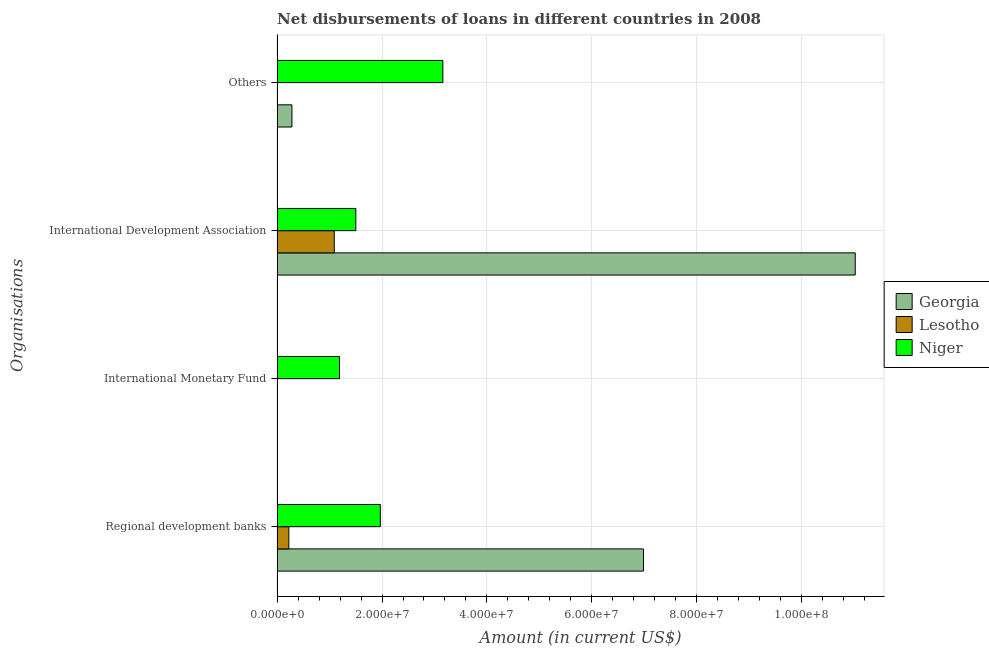How many different coloured bars are there?
Offer a terse response. 3. Are the number of bars per tick equal to the number of legend labels?
Your answer should be very brief. No. How many bars are there on the 1st tick from the bottom?
Make the answer very short. 3. What is the label of the 3rd group of bars from the top?
Provide a succinct answer. International Monetary Fund. What is the amount of loan disimbursed by international monetary fund in Niger?
Your answer should be very brief. 1.19e+07. Across all countries, what is the maximum amount of loan disimbursed by international monetary fund?
Offer a very short reply. 1.19e+07. In which country was the amount of loan disimbursed by international monetary fund maximum?
Offer a terse response. Niger. What is the total amount of loan disimbursed by other organisations in the graph?
Your response must be concise. 3.44e+07. What is the difference between the amount of loan disimbursed by international development association in Niger and that in Lesotho?
Make the answer very short. 4.11e+06. What is the difference between the amount of loan disimbursed by other organisations in Lesotho and the amount of loan disimbursed by international development association in Georgia?
Offer a very short reply. -1.10e+08. What is the average amount of loan disimbursed by international development association per country?
Ensure brevity in your answer.  4.54e+07. What is the difference between the amount of loan disimbursed by other organisations and amount of loan disimbursed by international development association in Niger?
Your answer should be compact. 1.66e+07. In how many countries, is the amount of loan disimbursed by international development association greater than 40000000 US$?
Provide a succinct answer. 1. What is the ratio of the amount of loan disimbursed by regional development banks in Niger to that in Georgia?
Your response must be concise. 0.28. Is the difference between the amount of loan disimbursed by regional development banks in Georgia and Niger greater than the difference between the amount of loan disimbursed by other organisations in Georgia and Niger?
Keep it short and to the point. Yes. What is the difference between the highest and the second highest amount of loan disimbursed by international development association?
Keep it short and to the point. 9.52e+07. What is the difference between the highest and the lowest amount of loan disimbursed by other organisations?
Offer a very short reply. 3.16e+07. Are all the bars in the graph horizontal?
Provide a succinct answer. Yes. Are the values on the major ticks of X-axis written in scientific E-notation?
Offer a very short reply. Yes. Does the graph contain any zero values?
Make the answer very short. Yes. Does the graph contain grids?
Offer a very short reply. Yes. Where does the legend appear in the graph?
Keep it short and to the point. Center right. How are the legend labels stacked?
Give a very brief answer. Vertical. What is the title of the graph?
Give a very brief answer. Net disbursements of loans in different countries in 2008. Does "High income: nonOECD" appear as one of the legend labels in the graph?
Ensure brevity in your answer.  No. What is the label or title of the X-axis?
Offer a terse response. Amount (in current US$). What is the label or title of the Y-axis?
Provide a short and direct response. Organisations. What is the Amount (in current US$) in Georgia in Regional development banks?
Your answer should be very brief. 6.99e+07. What is the Amount (in current US$) of Lesotho in Regional development banks?
Make the answer very short. 2.23e+06. What is the Amount (in current US$) of Niger in Regional development banks?
Make the answer very short. 1.97e+07. What is the Amount (in current US$) of Lesotho in International Monetary Fund?
Give a very brief answer. 0. What is the Amount (in current US$) in Niger in International Monetary Fund?
Keep it short and to the point. 1.19e+07. What is the Amount (in current US$) in Georgia in International Development Association?
Offer a terse response. 1.10e+08. What is the Amount (in current US$) in Lesotho in International Development Association?
Your answer should be compact. 1.09e+07. What is the Amount (in current US$) in Niger in International Development Association?
Your answer should be compact. 1.50e+07. What is the Amount (in current US$) in Georgia in Others?
Offer a very short reply. 2.82e+06. What is the Amount (in current US$) of Lesotho in Others?
Make the answer very short. 0. What is the Amount (in current US$) in Niger in Others?
Your answer should be very brief. 3.16e+07. Across all Organisations, what is the maximum Amount (in current US$) in Georgia?
Make the answer very short. 1.10e+08. Across all Organisations, what is the maximum Amount (in current US$) of Lesotho?
Your response must be concise. 1.09e+07. Across all Organisations, what is the maximum Amount (in current US$) of Niger?
Your answer should be very brief. 3.16e+07. Across all Organisations, what is the minimum Amount (in current US$) of Georgia?
Give a very brief answer. 0. Across all Organisations, what is the minimum Amount (in current US$) of Niger?
Provide a succinct answer. 1.19e+07. What is the total Amount (in current US$) of Georgia in the graph?
Your answer should be compact. 1.83e+08. What is the total Amount (in current US$) in Lesotho in the graph?
Ensure brevity in your answer.  1.31e+07. What is the total Amount (in current US$) of Niger in the graph?
Offer a terse response. 7.82e+07. What is the difference between the Amount (in current US$) in Niger in Regional development banks and that in International Monetary Fund?
Give a very brief answer. 7.79e+06. What is the difference between the Amount (in current US$) in Georgia in Regional development banks and that in International Development Association?
Provide a short and direct response. -4.04e+07. What is the difference between the Amount (in current US$) of Lesotho in Regional development banks and that in International Development Association?
Give a very brief answer. -8.66e+06. What is the difference between the Amount (in current US$) of Niger in Regional development banks and that in International Development Association?
Ensure brevity in your answer.  4.67e+06. What is the difference between the Amount (in current US$) in Georgia in Regional development banks and that in Others?
Provide a succinct answer. 6.70e+07. What is the difference between the Amount (in current US$) of Niger in Regional development banks and that in Others?
Make the answer very short. -1.19e+07. What is the difference between the Amount (in current US$) of Niger in International Monetary Fund and that in International Development Association?
Ensure brevity in your answer.  -3.12e+06. What is the difference between the Amount (in current US$) of Niger in International Monetary Fund and that in Others?
Make the answer very short. -1.97e+07. What is the difference between the Amount (in current US$) in Georgia in International Development Association and that in Others?
Give a very brief answer. 1.07e+08. What is the difference between the Amount (in current US$) in Niger in International Development Association and that in Others?
Your answer should be very brief. -1.66e+07. What is the difference between the Amount (in current US$) in Georgia in Regional development banks and the Amount (in current US$) in Niger in International Monetary Fund?
Your answer should be compact. 5.80e+07. What is the difference between the Amount (in current US$) in Lesotho in Regional development banks and the Amount (in current US$) in Niger in International Monetary Fund?
Give a very brief answer. -9.65e+06. What is the difference between the Amount (in current US$) of Georgia in Regional development banks and the Amount (in current US$) of Lesotho in International Development Association?
Ensure brevity in your answer.  5.90e+07. What is the difference between the Amount (in current US$) of Georgia in Regional development banks and the Amount (in current US$) of Niger in International Development Association?
Your answer should be compact. 5.48e+07. What is the difference between the Amount (in current US$) of Lesotho in Regional development banks and the Amount (in current US$) of Niger in International Development Association?
Make the answer very short. -1.28e+07. What is the difference between the Amount (in current US$) of Georgia in Regional development banks and the Amount (in current US$) of Niger in Others?
Provide a succinct answer. 3.83e+07. What is the difference between the Amount (in current US$) in Lesotho in Regional development banks and the Amount (in current US$) in Niger in Others?
Provide a succinct answer. -2.94e+07. What is the difference between the Amount (in current US$) of Georgia in International Development Association and the Amount (in current US$) of Niger in Others?
Provide a short and direct response. 7.86e+07. What is the difference between the Amount (in current US$) in Lesotho in International Development Association and the Amount (in current US$) in Niger in Others?
Your answer should be very brief. -2.07e+07. What is the average Amount (in current US$) in Georgia per Organisations?
Your answer should be compact. 4.57e+07. What is the average Amount (in current US$) of Lesotho per Organisations?
Offer a very short reply. 3.28e+06. What is the average Amount (in current US$) in Niger per Organisations?
Offer a terse response. 1.95e+07. What is the difference between the Amount (in current US$) of Georgia and Amount (in current US$) of Lesotho in Regional development banks?
Your response must be concise. 6.76e+07. What is the difference between the Amount (in current US$) in Georgia and Amount (in current US$) in Niger in Regional development banks?
Offer a terse response. 5.02e+07. What is the difference between the Amount (in current US$) in Lesotho and Amount (in current US$) in Niger in Regional development banks?
Keep it short and to the point. -1.74e+07. What is the difference between the Amount (in current US$) of Georgia and Amount (in current US$) of Lesotho in International Development Association?
Provide a short and direct response. 9.93e+07. What is the difference between the Amount (in current US$) in Georgia and Amount (in current US$) in Niger in International Development Association?
Provide a short and direct response. 9.52e+07. What is the difference between the Amount (in current US$) in Lesotho and Amount (in current US$) in Niger in International Development Association?
Your answer should be compact. -4.11e+06. What is the difference between the Amount (in current US$) of Georgia and Amount (in current US$) of Niger in Others?
Give a very brief answer. -2.88e+07. What is the ratio of the Amount (in current US$) of Niger in Regional development banks to that in International Monetary Fund?
Your answer should be compact. 1.66. What is the ratio of the Amount (in current US$) in Georgia in Regional development banks to that in International Development Association?
Offer a terse response. 0.63. What is the ratio of the Amount (in current US$) in Lesotho in Regional development banks to that in International Development Association?
Give a very brief answer. 0.2. What is the ratio of the Amount (in current US$) in Niger in Regional development banks to that in International Development Association?
Your answer should be very brief. 1.31. What is the ratio of the Amount (in current US$) in Georgia in Regional development banks to that in Others?
Offer a terse response. 24.74. What is the ratio of the Amount (in current US$) in Niger in Regional development banks to that in Others?
Your answer should be very brief. 0.62. What is the ratio of the Amount (in current US$) in Niger in International Monetary Fund to that in International Development Association?
Make the answer very short. 0.79. What is the ratio of the Amount (in current US$) of Niger in International Monetary Fund to that in Others?
Your response must be concise. 0.38. What is the ratio of the Amount (in current US$) in Georgia in International Development Association to that in Others?
Your response must be concise. 39.03. What is the ratio of the Amount (in current US$) of Niger in International Development Association to that in Others?
Provide a short and direct response. 0.47. What is the difference between the highest and the second highest Amount (in current US$) of Georgia?
Provide a succinct answer. 4.04e+07. What is the difference between the highest and the second highest Amount (in current US$) of Niger?
Keep it short and to the point. 1.19e+07. What is the difference between the highest and the lowest Amount (in current US$) of Georgia?
Your response must be concise. 1.10e+08. What is the difference between the highest and the lowest Amount (in current US$) in Lesotho?
Offer a terse response. 1.09e+07. What is the difference between the highest and the lowest Amount (in current US$) of Niger?
Keep it short and to the point. 1.97e+07. 